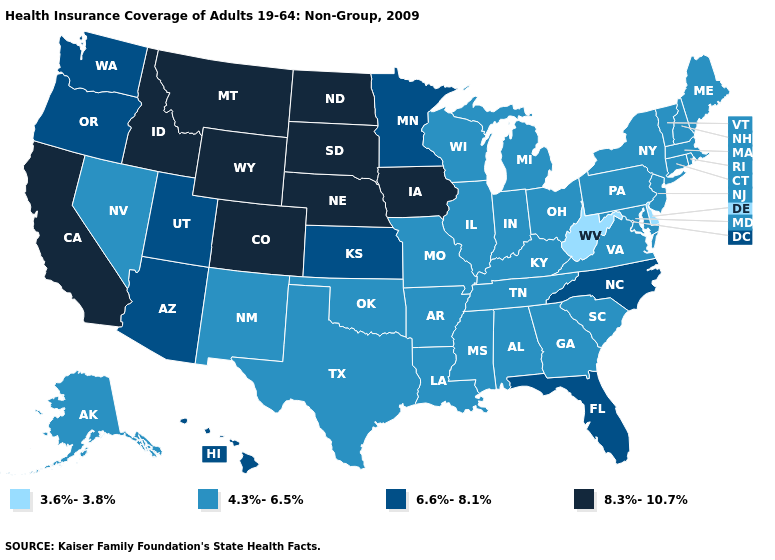What is the highest value in the USA?
Keep it brief. 8.3%-10.7%. Which states have the lowest value in the USA?
Give a very brief answer. Delaware, West Virginia. What is the lowest value in the MidWest?
Concise answer only. 4.3%-6.5%. What is the value of Michigan?
Quick response, please. 4.3%-6.5%. Name the states that have a value in the range 4.3%-6.5%?
Be succinct. Alabama, Alaska, Arkansas, Connecticut, Georgia, Illinois, Indiana, Kentucky, Louisiana, Maine, Maryland, Massachusetts, Michigan, Mississippi, Missouri, Nevada, New Hampshire, New Jersey, New Mexico, New York, Ohio, Oklahoma, Pennsylvania, Rhode Island, South Carolina, Tennessee, Texas, Vermont, Virginia, Wisconsin. What is the highest value in the West ?
Be succinct. 8.3%-10.7%. Name the states that have a value in the range 3.6%-3.8%?
Be succinct. Delaware, West Virginia. What is the value of Minnesota?
Quick response, please. 6.6%-8.1%. Does West Virginia have a lower value than Delaware?
Keep it brief. No. What is the lowest value in the Northeast?
Give a very brief answer. 4.3%-6.5%. Name the states that have a value in the range 8.3%-10.7%?
Short answer required. California, Colorado, Idaho, Iowa, Montana, Nebraska, North Dakota, South Dakota, Wyoming. What is the highest value in the West ?
Give a very brief answer. 8.3%-10.7%. What is the value of Maine?
Give a very brief answer. 4.3%-6.5%. 